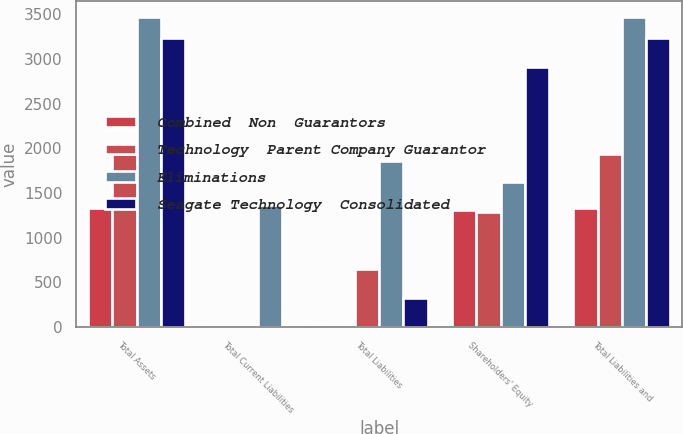Convert chart to OTSL. <chart><loc_0><loc_0><loc_500><loc_500><stacked_bar_chart><ecel><fcel>Total Assets<fcel>Total Current Liabilities<fcel>Total Liabilities<fcel>Shareholders' Equity<fcel>Total Liabilities and<nl><fcel>Combined  Non  Guarantors<fcel>1333<fcel>9<fcel>17<fcel>1316<fcel>1333<nl><fcel>Technology  Parent Company Guarantor<fcel>1941<fcel>7<fcel>653<fcel>1288<fcel>1941<nl><fcel>Eliminations<fcel>3474<fcel>1361<fcel>1855<fcel>1619<fcel>3474<nl><fcel>Seagate Technology  Consolidated<fcel>3231<fcel>14<fcel>324<fcel>2907<fcel>3231<nl></chart> 